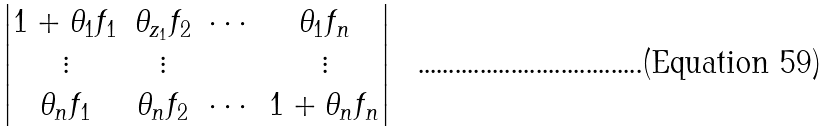Convert formula to latex. <formula><loc_0><loc_0><loc_500><loc_500>\begin{vmatrix} 1 + \theta _ { 1 } f _ { 1 } & \theta _ { z _ { 1 } } f _ { 2 } & \cdots & \theta _ { 1 } f _ { n } \\ \vdots & \vdots & & \vdots \\ \theta _ { n } f _ { 1 } & \theta _ { n } f _ { 2 } & \cdots & 1 + \theta _ { n } f _ { n } \end{vmatrix}</formula> 